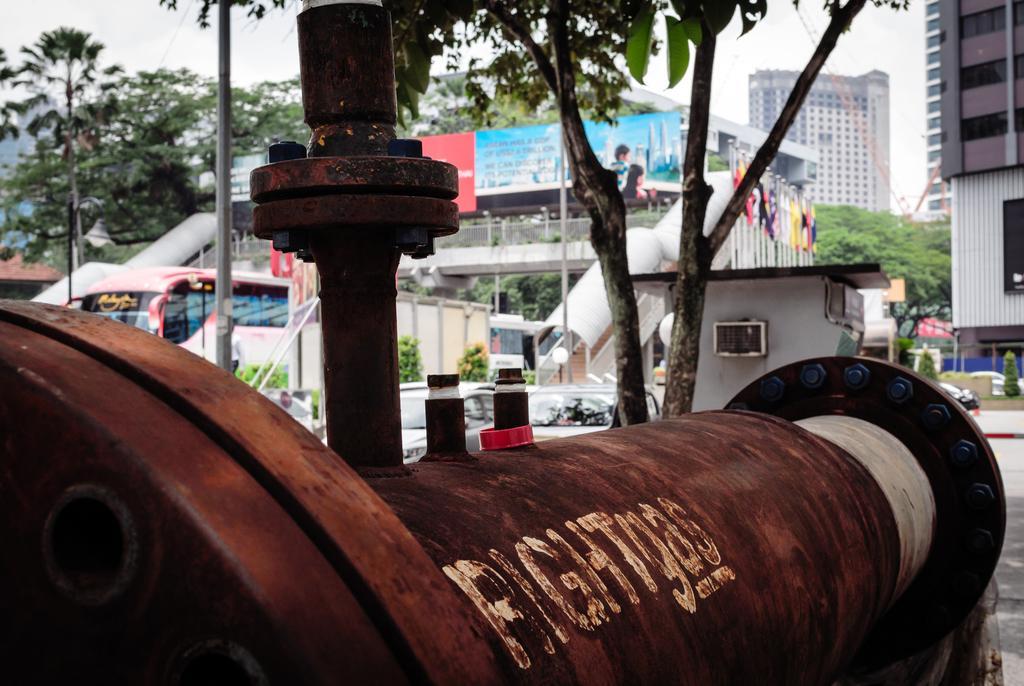Please provide a concise description of this image. Here in this picture we can see a pipe present on the ground over there and in the far we can see number of buildings and we can see staircase with a foot over bridge present in the middle over there and we can see buses on the road and we can see plants and trees here and there and we can see banners present over there. 